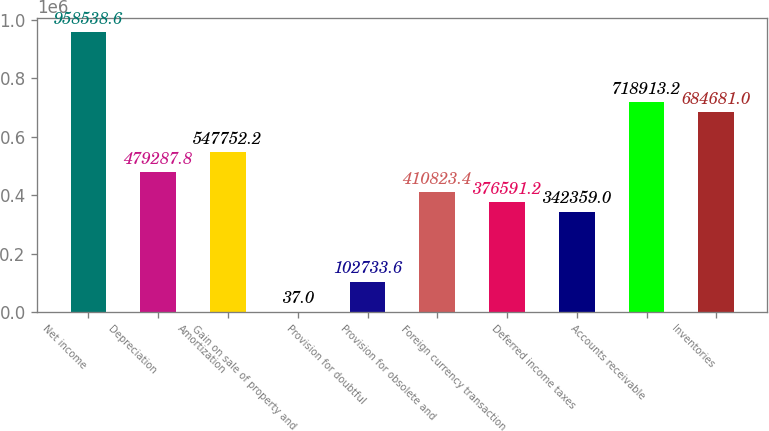<chart> <loc_0><loc_0><loc_500><loc_500><bar_chart><fcel>Net income<fcel>Depreciation<fcel>Amortization<fcel>Gain on sale of property and<fcel>Provision for doubtful<fcel>Provision for obsolete and<fcel>Foreign currency transaction<fcel>Deferred income taxes<fcel>Accounts receivable<fcel>Inventories<nl><fcel>958539<fcel>479288<fcel>547752<fcel>37<fcel>102734<fcel>410823<fcel>376591<fcel>342359<fcel>718913<fcel>684681<nl></chart> 